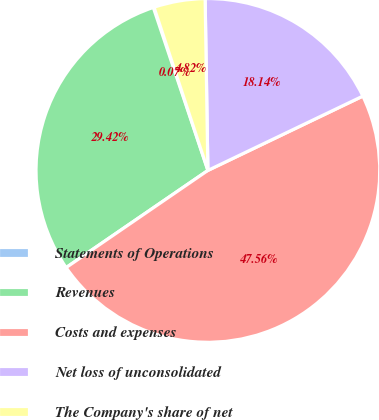Convert chart. <chart><loc_0><loc_0><loc_500><loc_500><pie_chart><fcel>Statements of Operations<fcel>Revenues<fcel>Costs and expenses<fcel>Net loss of unconsolidated<fcel>The Company's share of net<nl><fcel>0.07%<fcel>29.42%<fcel>47.56%<fcel>18.14%<fcel>4.82%<nl></chart> 